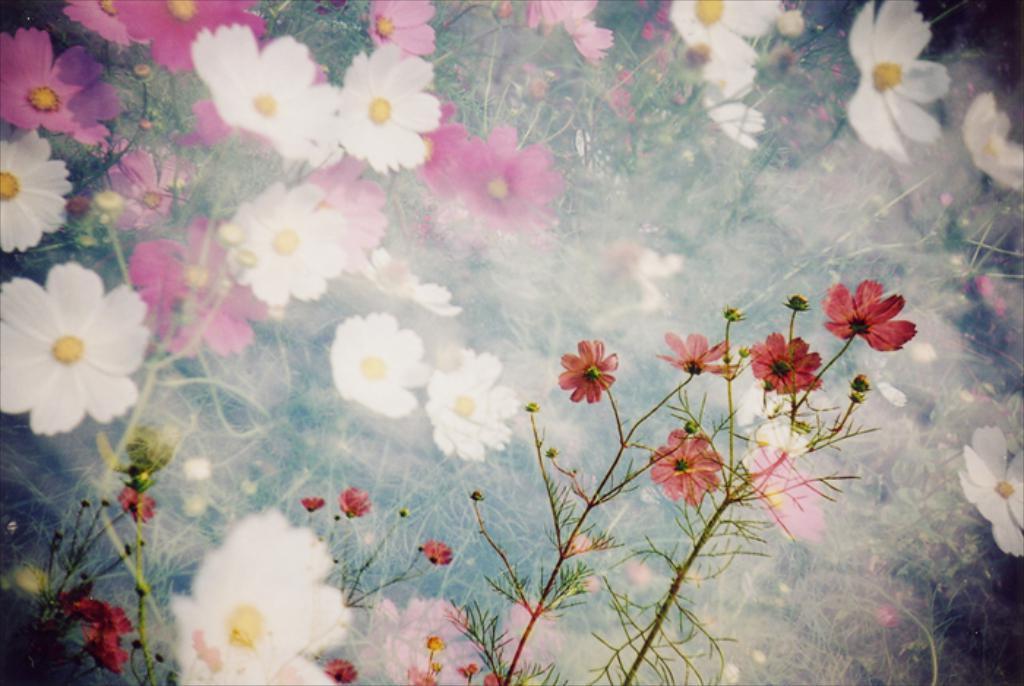Could you give a brief overview of what you see in this image? This is an edited image, we can see there are plants with flowers and buds. 